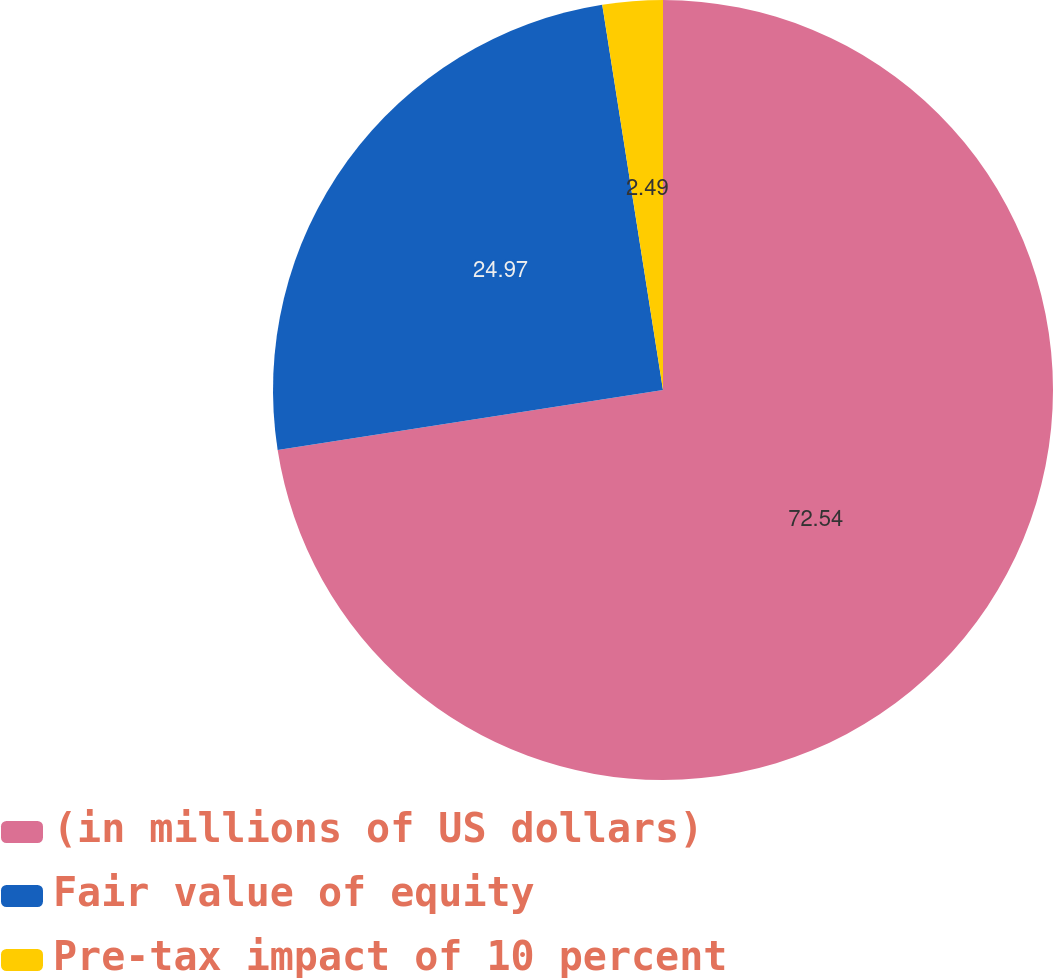Convert chart to OTSL. <chart><loc_0><loc_0><loc_500><loc_500><pie_chart><fcel>(in millions of US dollars)<fcel>Fair value of equity<fcel>Pre-tax impact of 10 percent<nl><fcel>72.54%<fcel>24.97%<fcel>2.49%<nl></chart> 